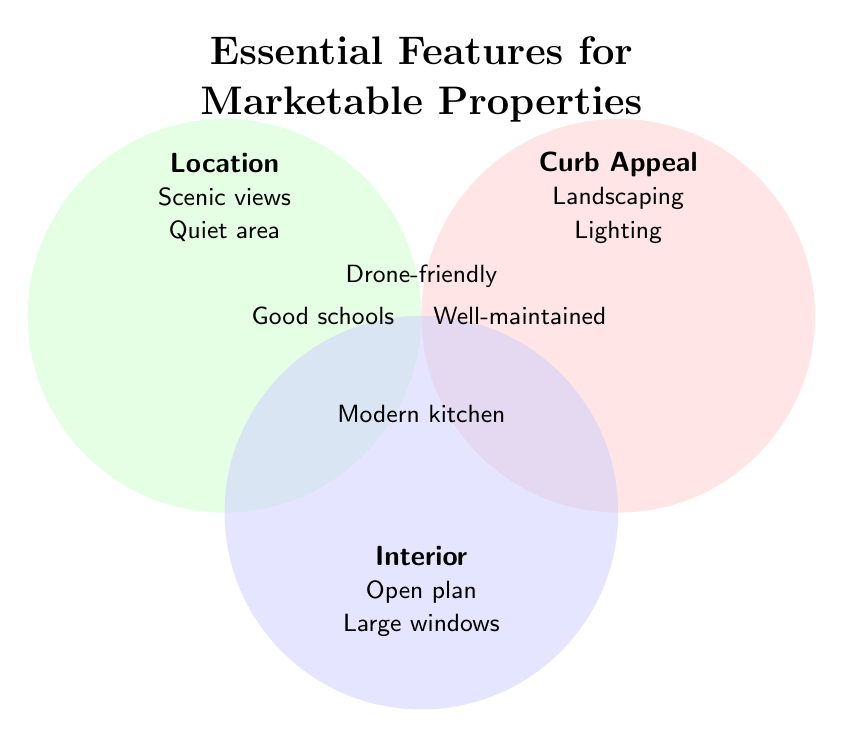What are the three main categories of features for marketable properties? The Venn Diagram is divided into three labeled sections: Location, Curb Appeal, and Interior. These represent the main categories.
Answer: Location, Curb Appeal, Interior What feature is common to all three categories? The center of the Venn Diagram, where the three circles overlap, is labeled "Drone-friendly." This indicates that Drone-friendly is common to all three categories.
Answer: Drone-friendly Which features are exclusive to the Location category? The features listed solely in the Location circle but not overlapping with other circles are Scenic views and Quiet area.
Answer: Scenic views, Quiet area Are there any features that overlap between Location and Curb Appeal but not Interior? The overlap between the Location and Curb Appeal circles but not touching the Interior circle is labeled "Good schools."
Answer: Good schools Which category includes "Large windows"? "Large windows" is listed under the Interior category.
Answer: Interior What feature is shared between Curb Appeal and Interior? The features listed in the overlapping region between Curb Appeal and Interior are "Well-maintained" and "Modern kitchen."
Answer: Modern kitchen, Well-maintained Which feature belongs to the intersection of Location and Interior? The feature listed in the overlapping region between Location and Interior is "Modern kitchen."
Answer: Modern kitchen Does the "Open plan" fall under Curb Appeal? "Open plan" is listed under the Interior category only. Therefore, it does not fall under Curb Appeal.
Answer: No What features are only in Curb Appeal and not shared with others? The features listed solely in the Curb Appeal circle are Landscaping and Lighting.
Answer: Landscaping, Lighting Which features are highlighted for good school districts and well-maintained exteriors? "Good schools" is a feature found in the Location and Curb Appeal intersecting area. "Well-maintained" is found in the Curb Appeal and Interior intersecting area.
Answer: Good schools, Well-maintained 